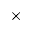<formula> <loc_0><loc_0><loc_500><loc_500>\times</formula> 